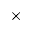<formula> <loc_0><loc_0><loc_500><loc_500>\times</formula> 